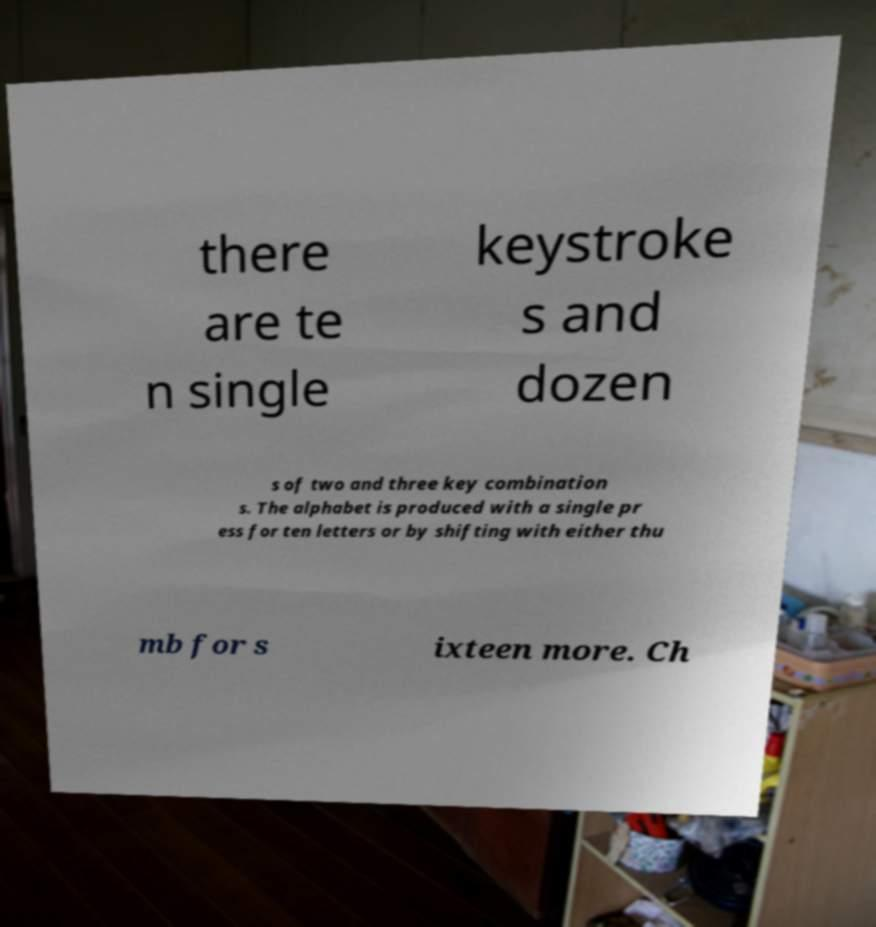Can you read and provide the text displayed in the image?This photo seems to have some interesting text. Can you extract and type it out for me? there are te n single keystroke s and dozen s of two and three key combination s. The alphabet is produced with a single pr ess for ten letters or by shifting with either thu mb for s ixteen more. Ch 